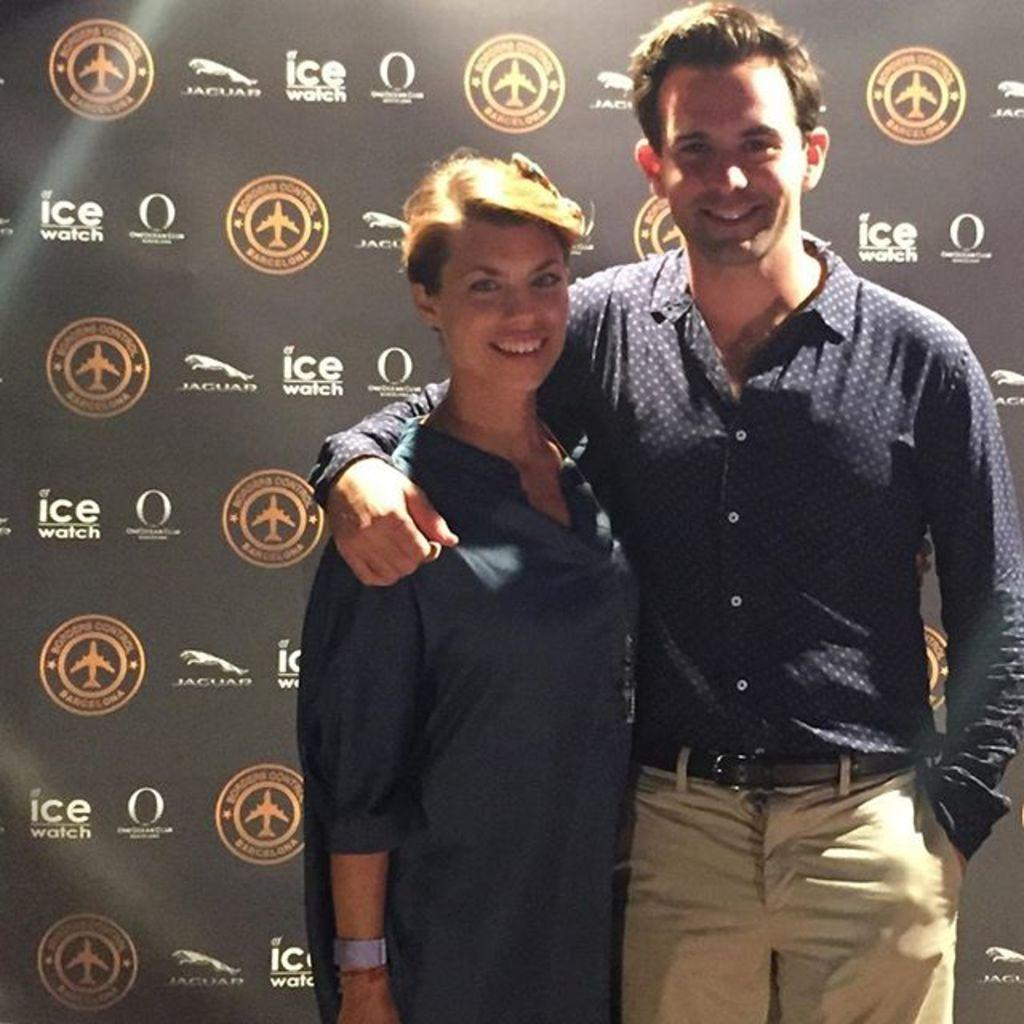How many people are present in the image? There are two people in the image, a man and a woman. What are the man and the woman doing in the image? Both the man and the woman are standing and smiling. What can be seen in the background of the image? There is a banner in the background of the image. What type of cracker is the man holding in the image? There is no cracker present in the image; both the man and the woman are standing without any objects in their hands. Can you tell me how high the lift is in the image? There is no lift present in the image; it is a scene featuring a man and a woman standing and smiling with a banner in the background. 